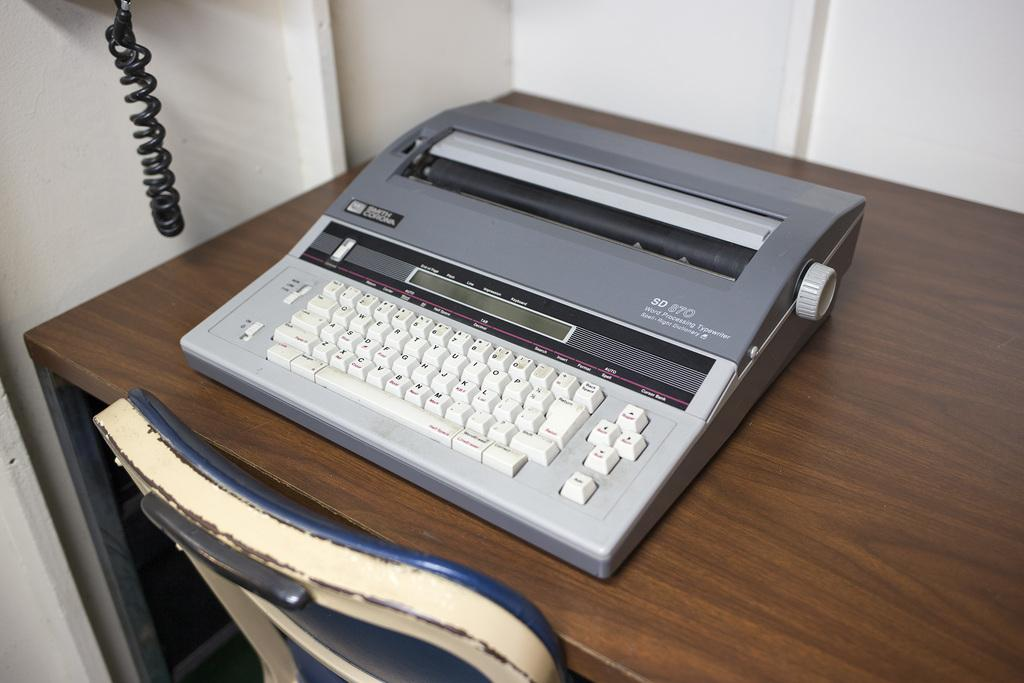<image>
Present a compact description of the photo's key features. A Smith Corona electric typewriter sitting on a table. 